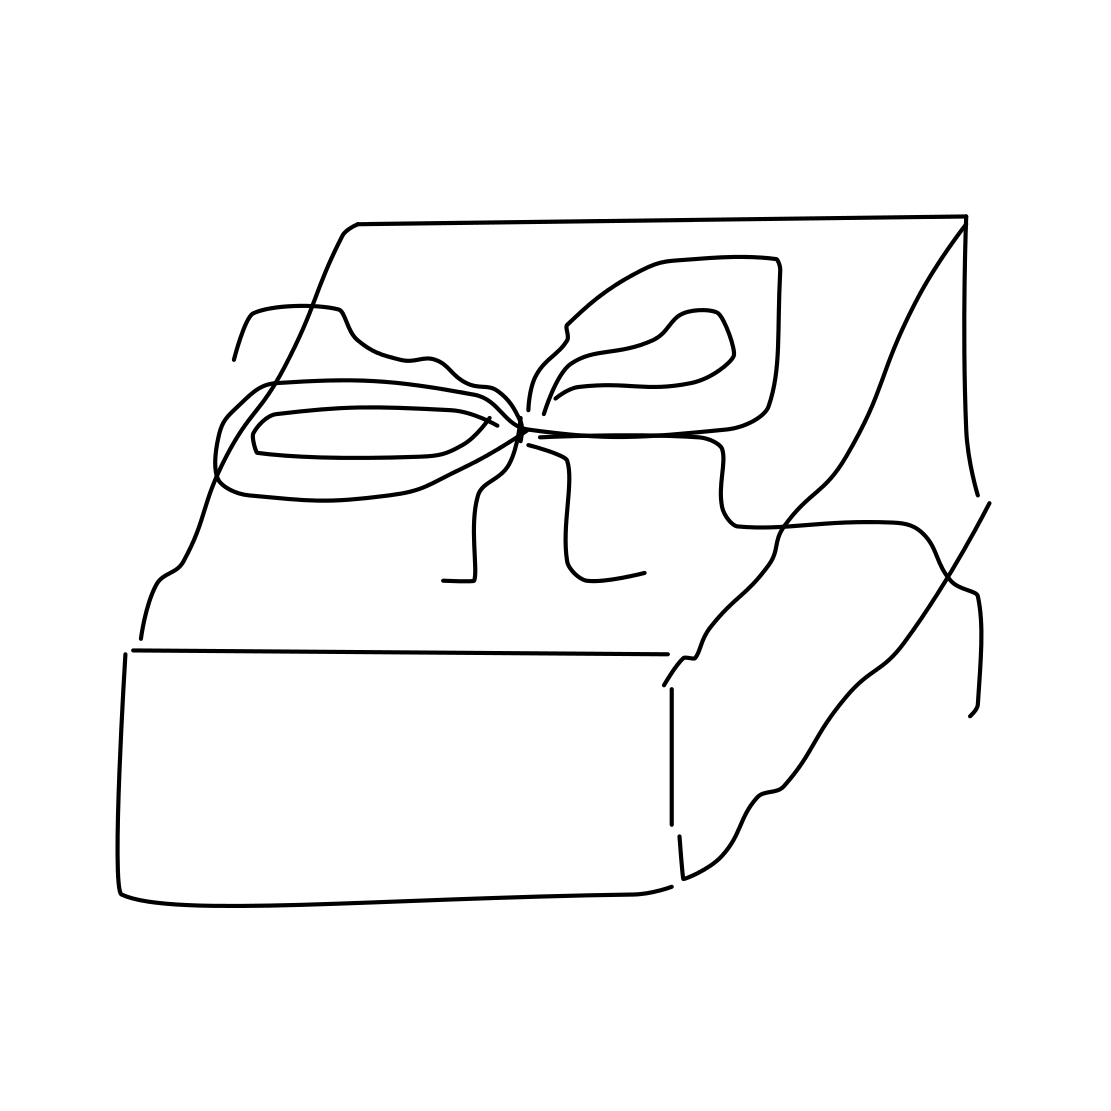From this image, can we infer something about the person giving or receiving the gift? Based solely on this image, it's difficult to make precise assumptions about the people involved. However, the neat presentation of the gift can suggest that the giver values thoughtfulness and has taken care to present something special, indicating a likely meaningful relationship with the recipient. 